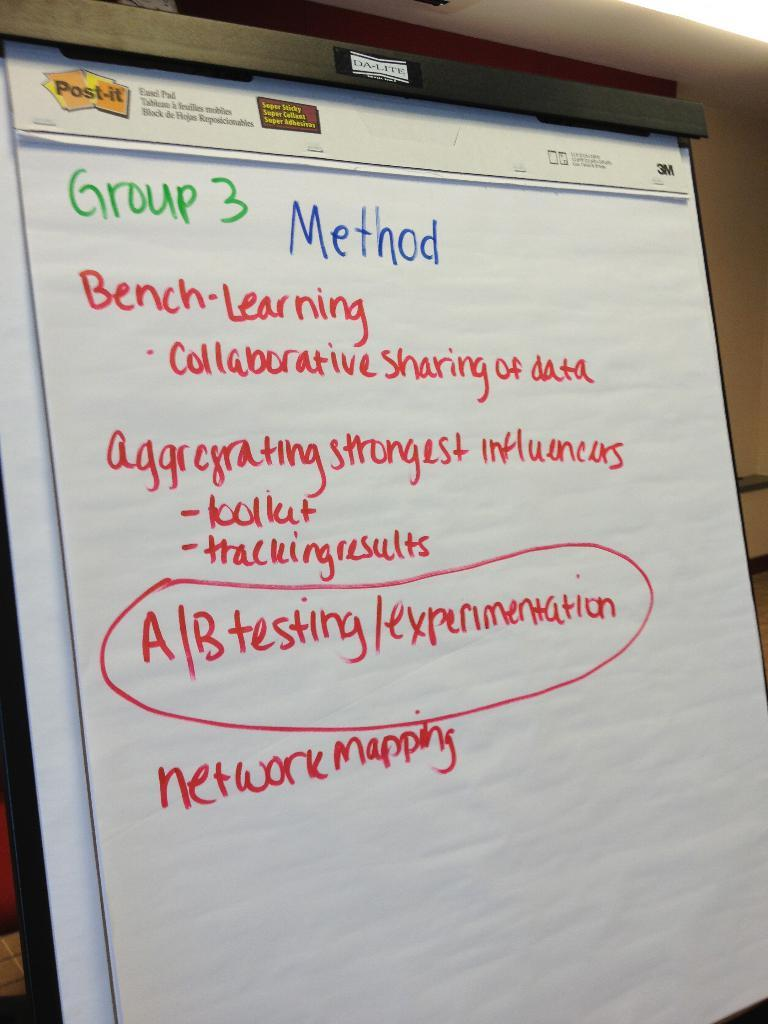<image>
Offer a succinct explanation of the picture presented. In a school, a group is using a four-step methodology for a problem. 